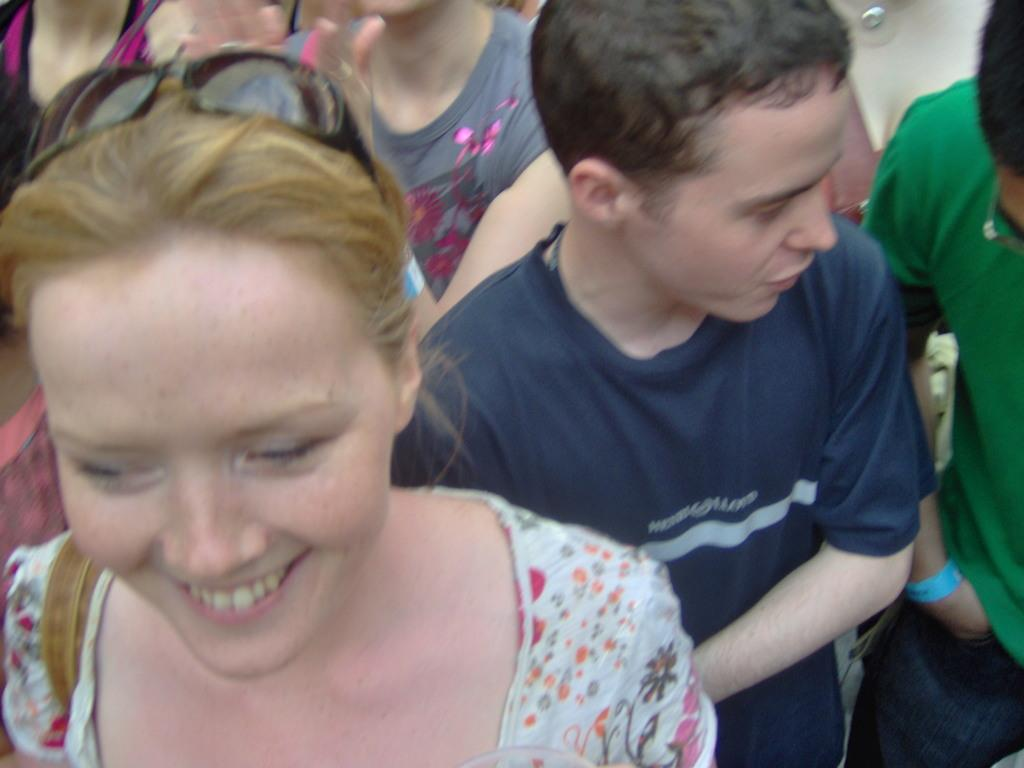How many persons are in the image? There are few persons in the image. Can you describe the expression of one of the persons? One of the persons is smiling. What type of heat source can be seen in the image? There is no heat source present in the image. What type of cabbage is being used as a prop in the image? There is no cabbage present in the image. What type of sign is being held by one of the persons in the image? There is no sign present in the image. 